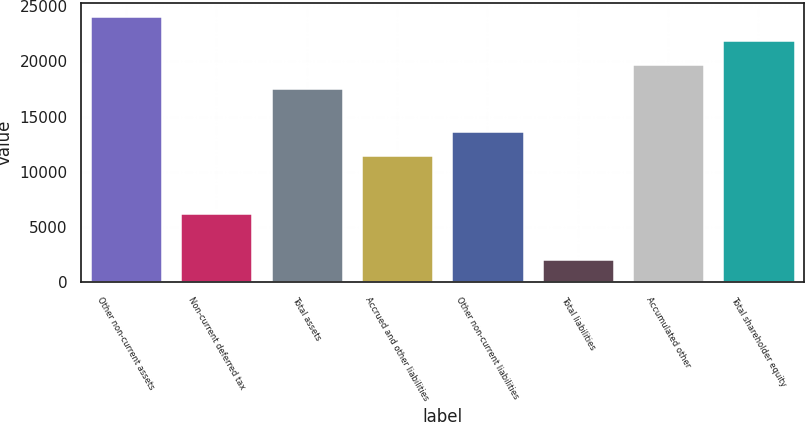Convert chart. <chart><loc_0><loc_0><loc_500><loc_500><bar_chart><fcel>Other non-current assets<fcel>Non-current deferred tax<fcel>Total assets<fcel>Accrued and other liabilities<fcel>Other non-current liabilities<fcel>Total liabilities<fcel>Accumulated other<fcel>Total shareholder equity<nl><fcel>24071.1<fcel>6307<fcel>17544<fcel>11545<fcel>13720.7<fcel>2094<fcel>19719.7<fcel>21895.4<nl></chart> 